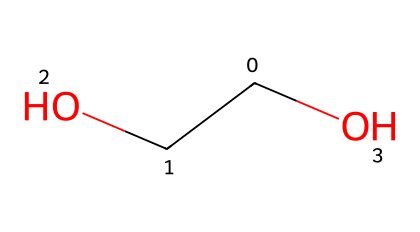What is the molecular formula of polyethylene oxide? By analyzing the structure represented by the given SMILES, we can identify the types and numbers of atoms present. This chemical contains two carbon atoms (C), four hydrogen atoms (H), and one oxygen atom (O). Thus, the molecular formula comprises 2 carbon, 4 hydrogen, and 1 oxygen.
Answer: C2H4O How many oxygen atoms are present in this chemical structure? By examining the chemical structure (from the SMILES), we see that there is one oxygen atom represented. This is identified directly from the presence of 'O' in the SMILES string.
Answer: 1 What type of functional group is present in polyethylene oxide? The presence of an 'O' connected to the carbon (from the -COOH group) indicates that this molecule contains a hydroxyl (alcohol) functional group. This is relevant as polyethylene oxide is known for its solubility in water due to such functional groups.
Answer: hydroxyl How does this chemical behave as a Non-Newtonian fluid? Polyethylene oxide exhibits shear-thinning behavior, meaning its viscosity decreases under shear stress. The molecular weight and structure influence how it responds to stress and strain, which is essential for its application in cooling systems.
Answer: shear-thinning What physical property allows polyethylene oxide to be used in cooling systems? The ability of polyethylene oxide to dissolve in water and form viscous solutions allows for effective heat transfer and cooling. This property is pivotal for its application in high-performance computing environments.
Answer: viscosity 